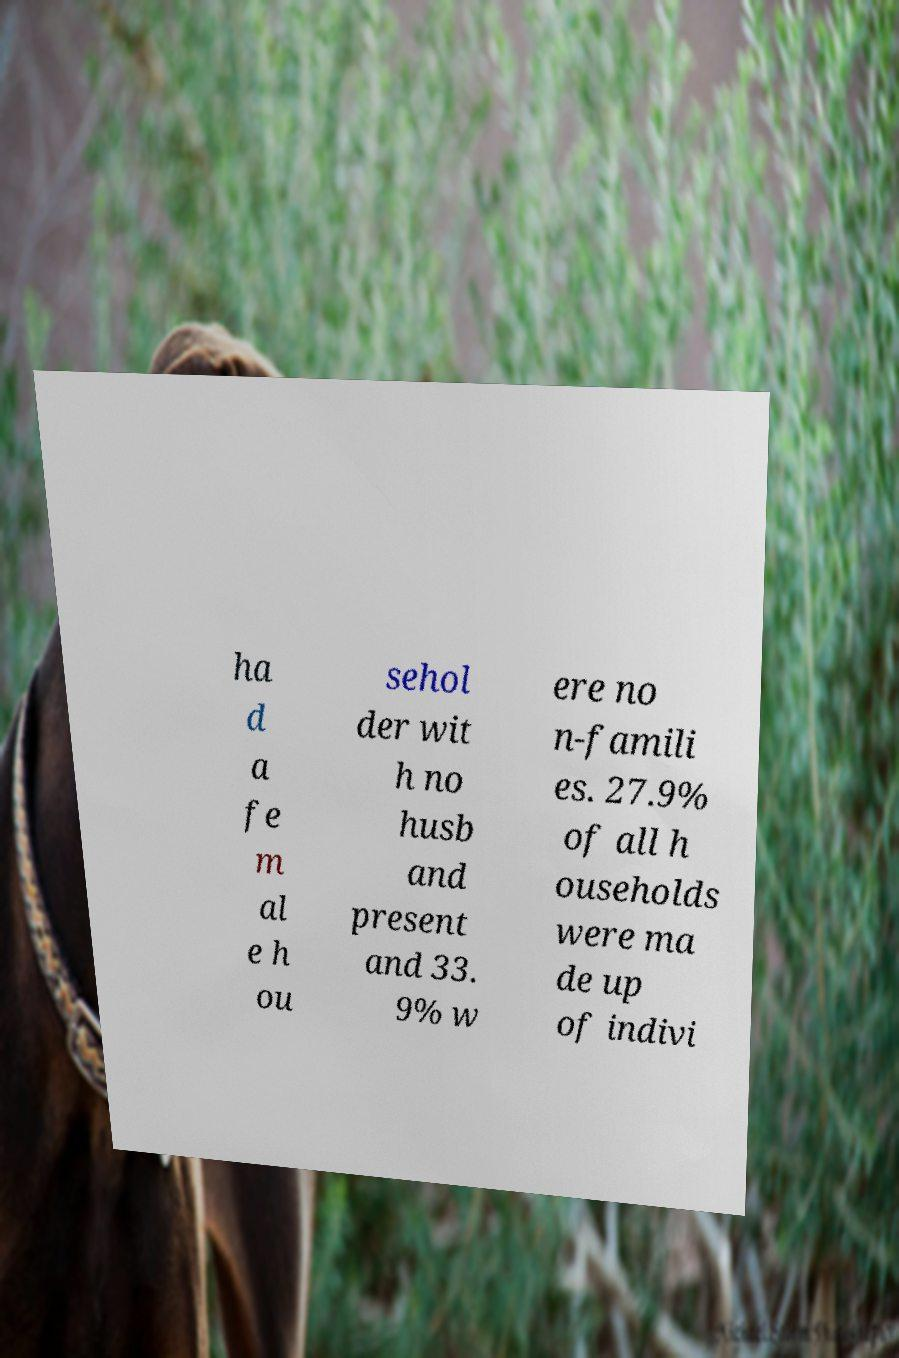What messages or text are displayed in this image? I need them in a readable, typed format. ha d a fe m al e h ou sehol der wit h no husb and present and 33. 9% w ere no n-famili es. 27.9% of all h ouseholds were ma de up of indivi 